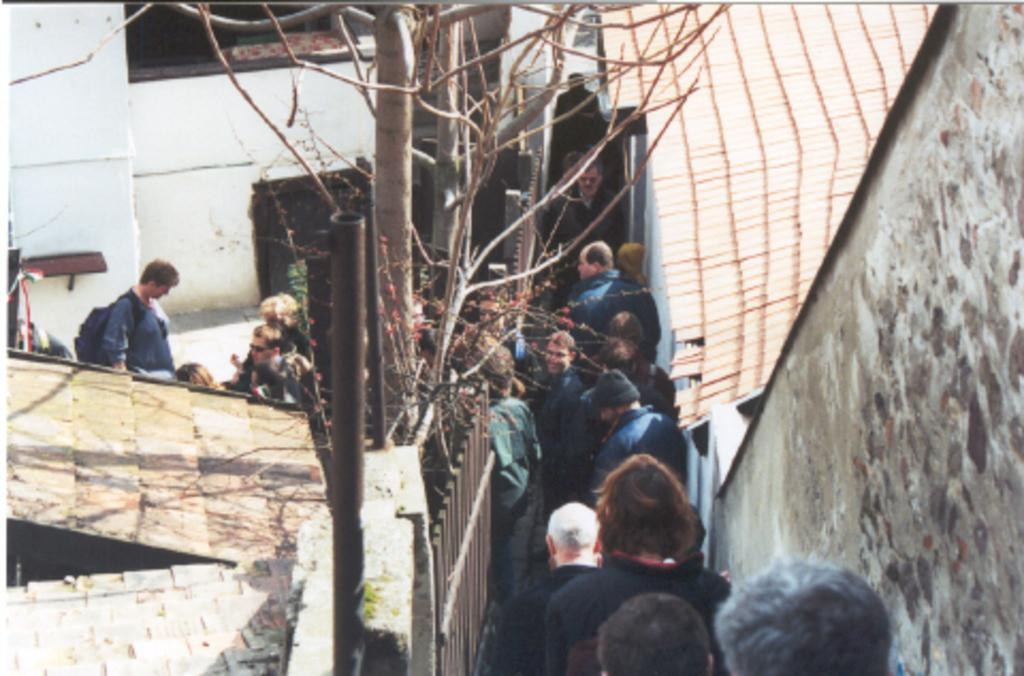What type of structures can be seen in the image? There are buildings and walls in the image. What natural elements are present in the image? There are trees in the image. What type of barrier can be seen in the image? There is a fence in the image. What vertical object is present in the image? There is a pole in the image. What personal item can be seen in the image? There is a bag in the image. Who is present in the image? There is a group of people in the image. What additional objects can be seen in the image? There are some objects in the image. How does the arm of the person in the image support the control panel? There is no person or control panel present in the image. 